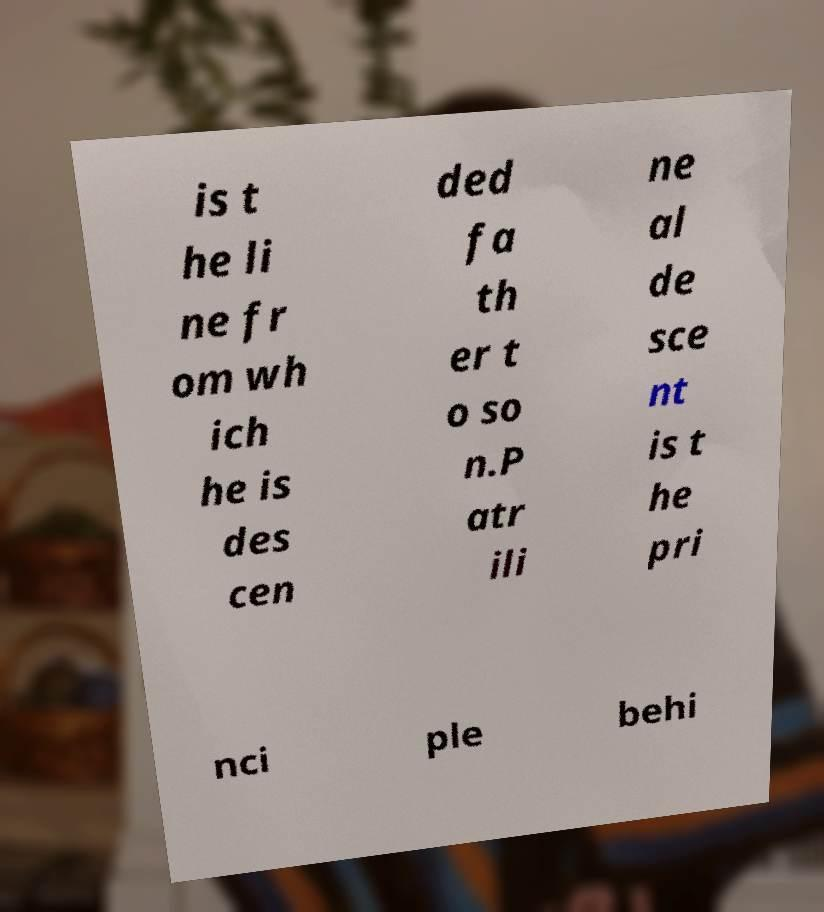There's text embedded in this image that I need extracted. Can you transcribe it verbatim? is t he li ne fr om wh ich he is des cen ded fa th er t o so n.P atr ili ne al de sce nt is t he pri nci ple behi 